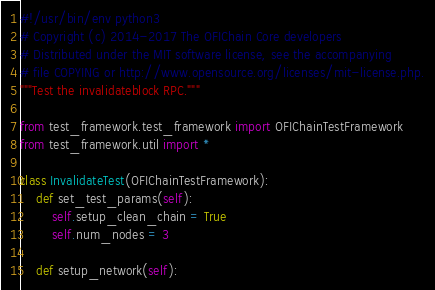<code> <loc_0><loc_0><loc_500><loc_500><_Python_>#!/usr/bin/env python3
# Copyright (c) 2014-2017 The OFIChain Core developers
# Distributed under the MIT software license, see the accompanying
# file COPYING or http://www.opensource.org/licenses/mit-license.php.
"""Test the invalidateblock RPC."""

from test_framework.test_framework import OFIChainTestFramework
from test_framework.util import *

class InvalidateTest(OFIChainTestFramework):
    def set_test_params(self):
        self.setup_clean_chain = True
        self.num_nodes = 3

    def setup_network(self):</code> 